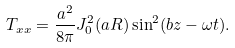<formula> <loc_0><loc_0><loc_500><loc_500>T _ { x x } = \frac { a ^ { 2 } } { 8 \pi } J _ { 0 } ^ { 2 } ( a R ) \sin ^ { 2 } ( b z - \omega t ) .</formula> 